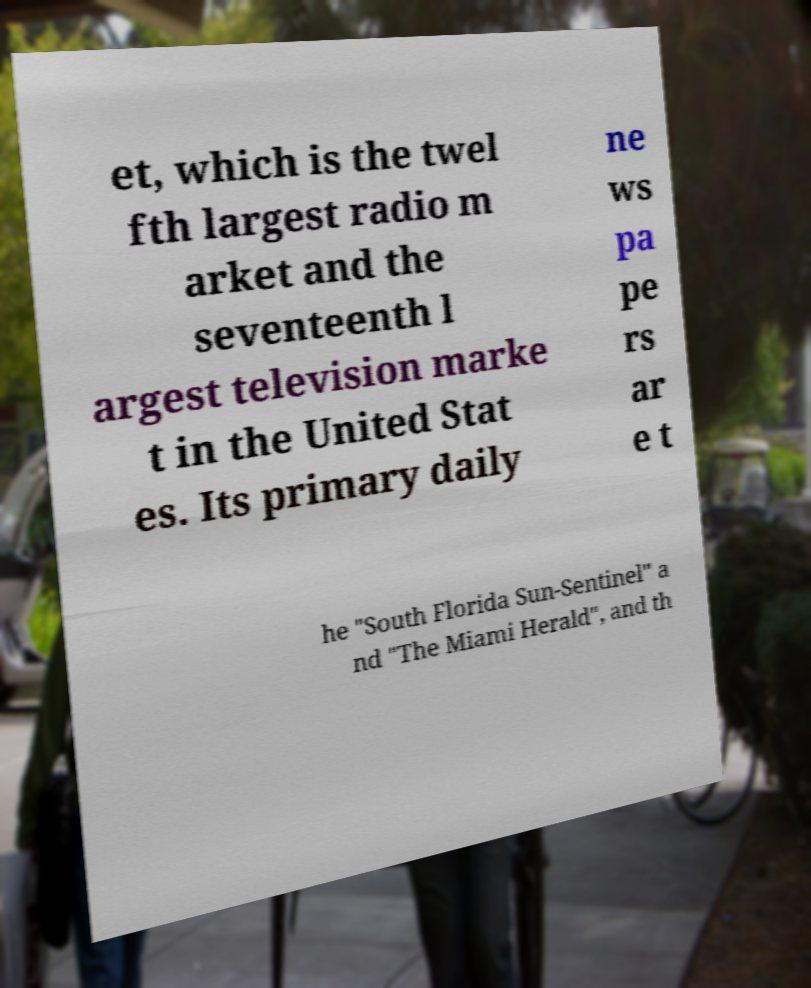Can you accurately transcribe the text from the provided image for me? et, which is the twel fth largest radio m arket and the seventeenth l argest television marke t in the United Stat es. Its primary daily ne ws pa pe rs ar e t he "South Florida Sun-Sentinel" a nd "The Miami Herald", and th 